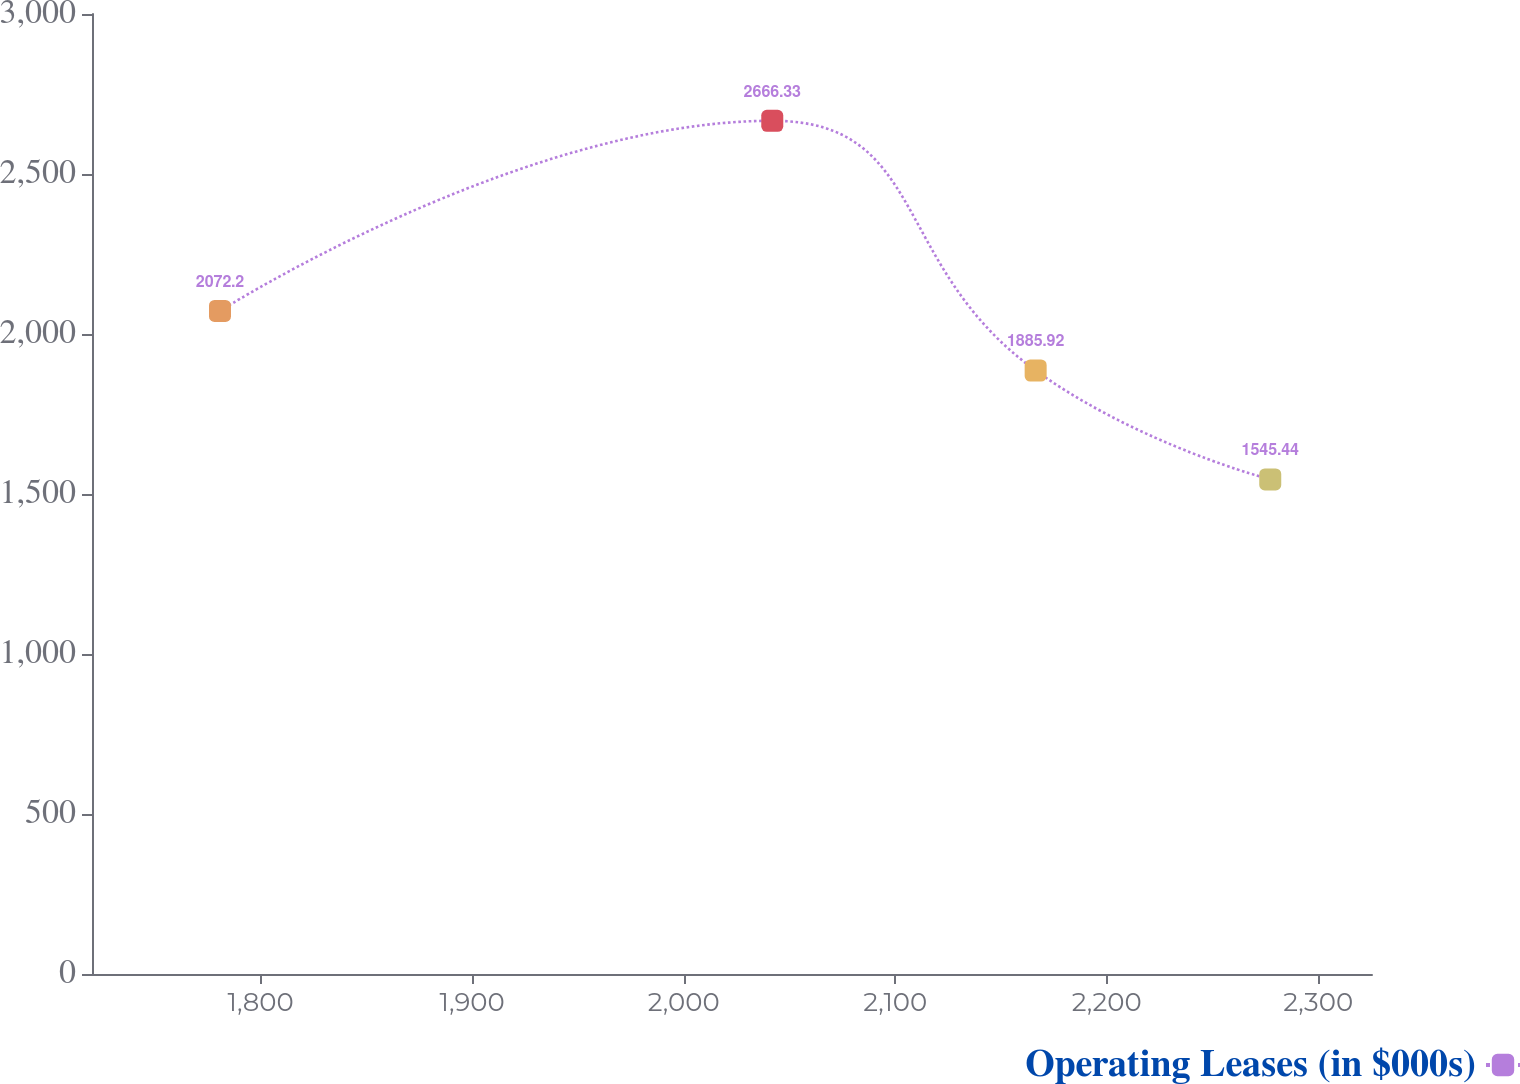Convert chart. <chart><loc_0><loc_0><loc_500><loc_500><line_chart><ecel><fcel>Operating Leases (in $000s)<nl><fcel>1780.77<fcel>2072.2<nl><fcel>2041.87<fcel>2666.33<nl><fcel>2166.39<fcel>1885.92<nl><fcel>2277.3<fcel>1545.44<nl><fcel>2385.92<fcel>803.48<nl></chart> 